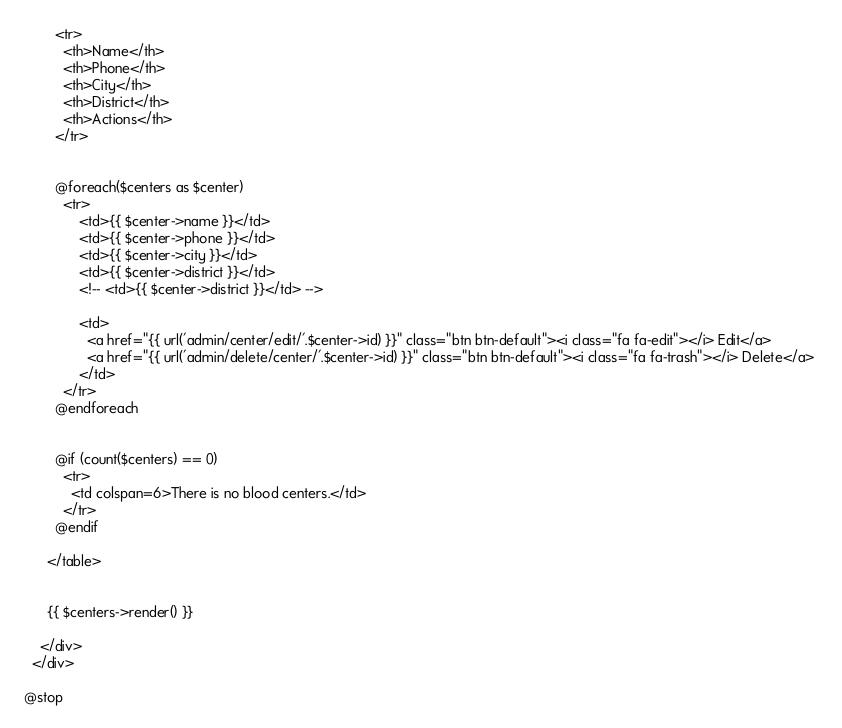<code> <loc_0><loc_0><loc_500><loc_500><_PHP_>        <tr>
          <th>Name</th>
          <th>Phone</th>
          <th>City</th>
          <th>District</th>
          <th>Actions</th>
        </tr>


        @foreach($centers as $center)
          <tr>
              <td>{{ $center->name }}</td>
              <td>{{ $center->phone }}</td>
              <td>{{ $center->city }}</td>
              <td>{{ $center->district }}</td>
              <!-- <td>{{ $center->district }}</td> -->
              
              <td> 
                <a href="{{ url('admin/center/edit/'.$center->id) }}" class="btn btn-default"><i class="fa fa-edit"></i> Edit</a> 
                <a href="{{ url('admin/delete/center/'.$center->id) }}" class="btn btn-default"><i class="fa fa-trash"></i> Delete</a> 
              </td>
          </tr>
        @endforeach


        @if (count($centers) == 0)
          <tr>
            <td colspan=6>There is no blood centers.</td>
          </tr>
        @endif

      </table>


      {{ $centers->render() }}

    </div>
  </div>

@stop
</code> 